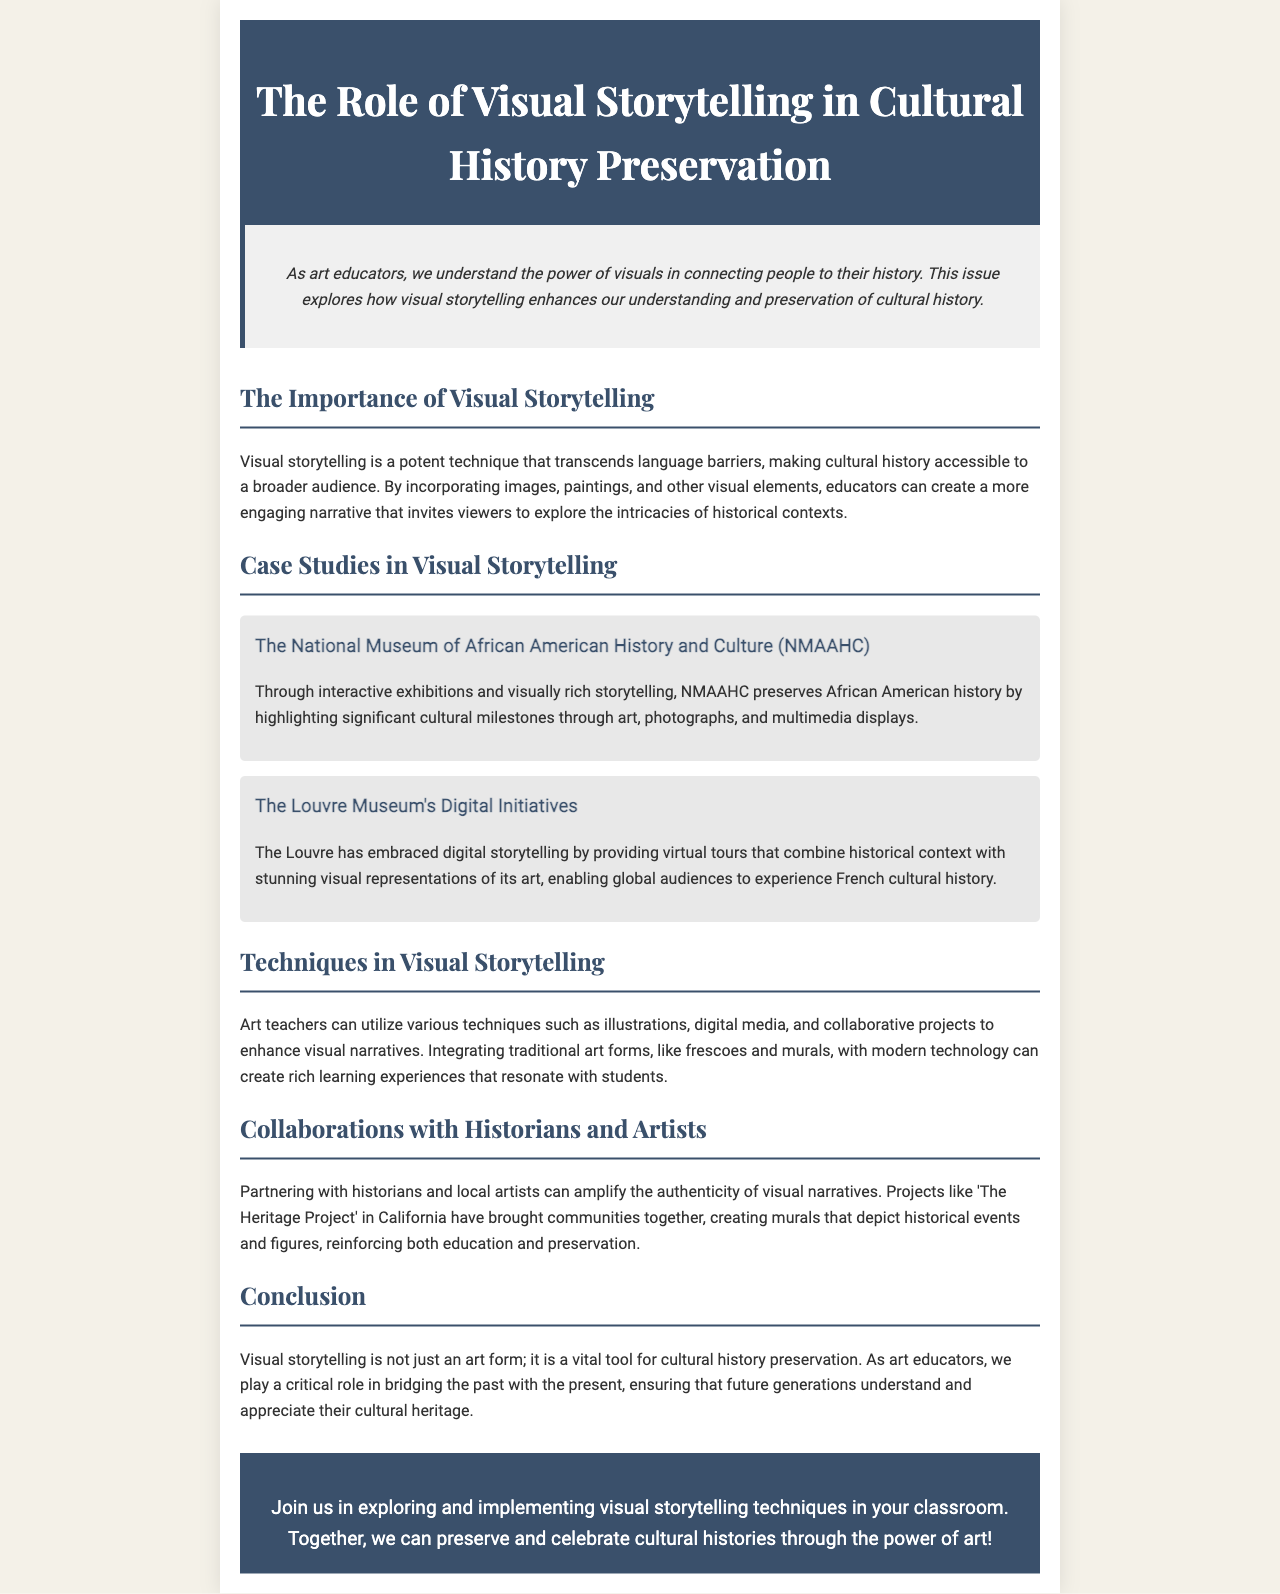what is the title of the newsletter? The title is provided in the header section of the document, which states "The Role of Visual Storytelling in Cultural History Preservation."
Answer: The Role of Visual Storytelling in Cultural History Preservation what does the intro paragraph emphasize? The introduction highlights the significance of visuals in connecting people to their history, which is a primary theme of the newsletter.
Answer: The power of visuals in connecting people to their history which museum focuses on African American history? The document mentions a specific museum dedicated to African American history in its case studies section.
Answer: The National Museum of African American History and Culture how are virtual tours utilized by the Louvre Museum? The Louvre Museum uses virtual tours to provide historical context combined with visual representations to enhance the audience's experience.
Answer: Digital storytelling what is a technique mentioned for enhancing visual narratives? The document lists various techniques that art teachers can use to improve storytelling visually, like blending traditional and modern art forms.
Answer: Illustrations what is one example of a collaboration mentioned in the document? The newsletter discusses project collaborations such as 'The Heritage Project,' which involves community engagement in art creation.
Answer: The Heritage Project what role do art educators play according to the conclusion? The conclusion outlines the responsibility of art educators in connecting cultural heritage with present knowledge, emphasizing education's importance.
Answer: Bridging the past with the present how can visual storytelling impact cultural history? The newsletter identifies the benefits of visual storytelling in making cultural history more accessible and engaging for audiences.
Answer: A vital tool for cultural history preservation 